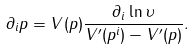Convert formula to latex. <formula><loc_0><loc_0><loc_500><loc_500>\partial _ { i } p = V ( p ) \frac { \partial _ { i } \ln \upsilon } { V ^ { \prime } ( p ^ { i } ) - V ^ { \prime } ( p ) } .</formula> 